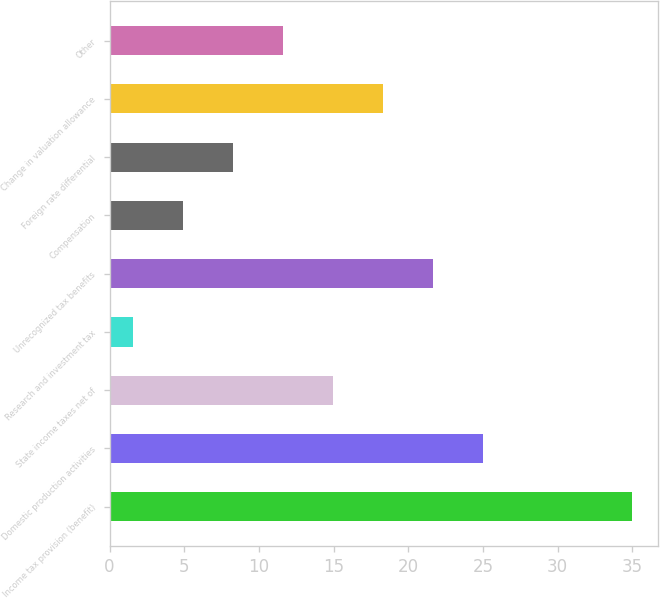Convert chart. <chart><loc_0><loc_0><loc_500><loc_500><bar_chart><fcel>Income tax provision (benefit)<fcel>Domestic production activities<fcel>State income taxes net of<fcel>Research and investment tax<fcel>Unrecognized tax benefits<fcel>Compensation<fcel>Foreign rate differential<fcel>Change in valuation allowance<fcel>Other<nl><fcel>35<fcel>24.98<fcel>14.96<fcel>1.6<fcel>21.64<fcel>4.94<fcel>8.28<fcel>18.3<fcel>11.62<nl></chart> 